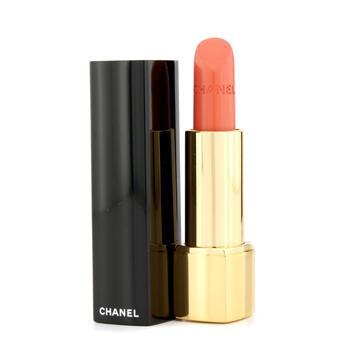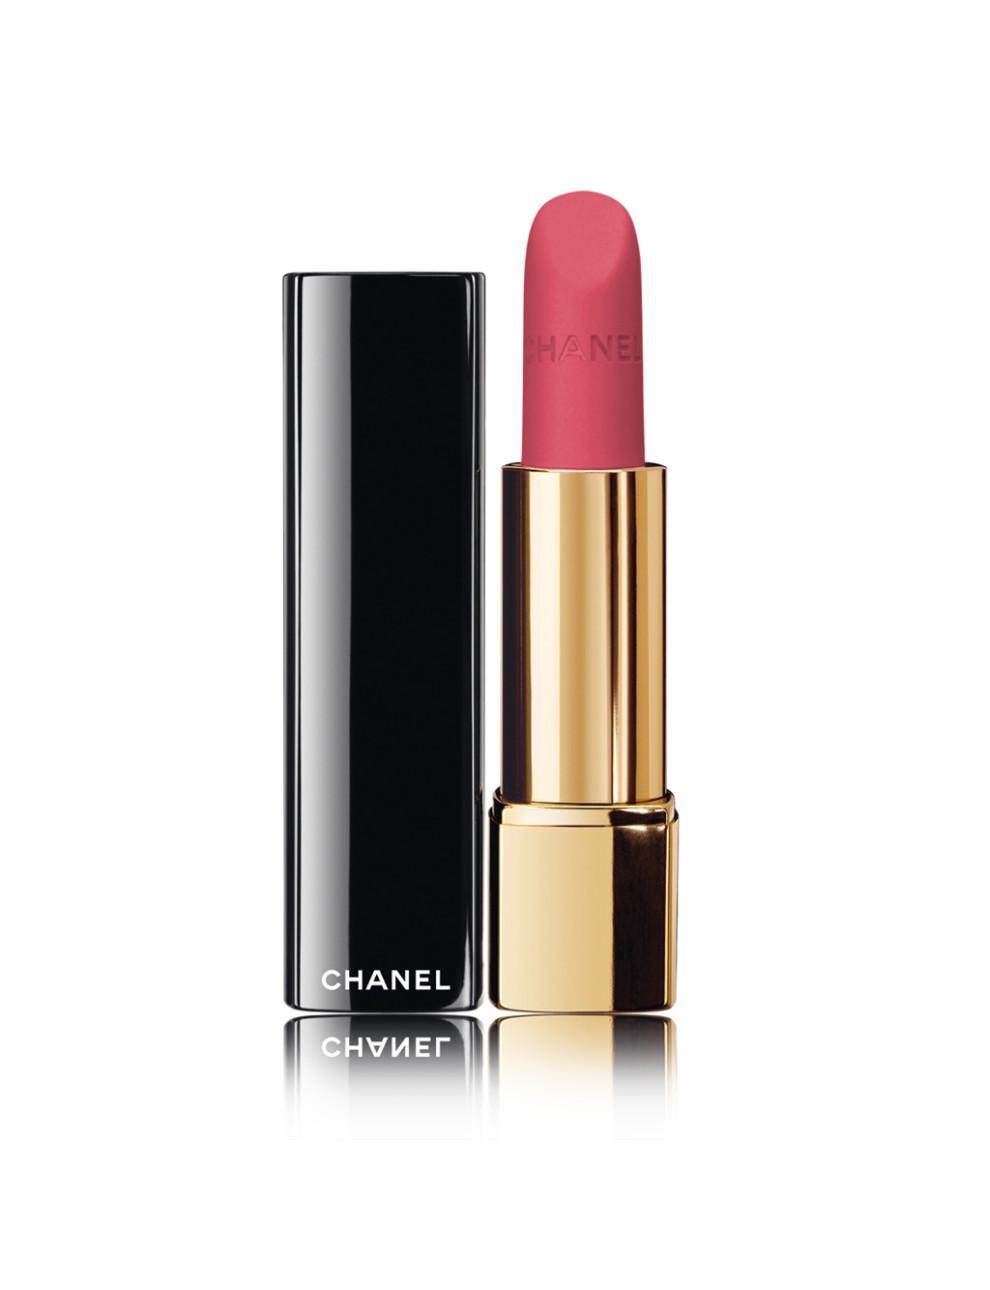The first image is the image on the left, the second image is the image on the right. Analyze the images presented: Is the assertion "One lipstick is extended to show its color with its cap sitting beside it, while a second lipstick is closed, but with a visible color." valid? Answer yes or no. No. The first image is the image on the left, the second image is the image on the right. Assess this claim about the two images: "An image features one orange lipstick standing next to its upright lid.". Correct or not? Answer yes or no. Yes. 